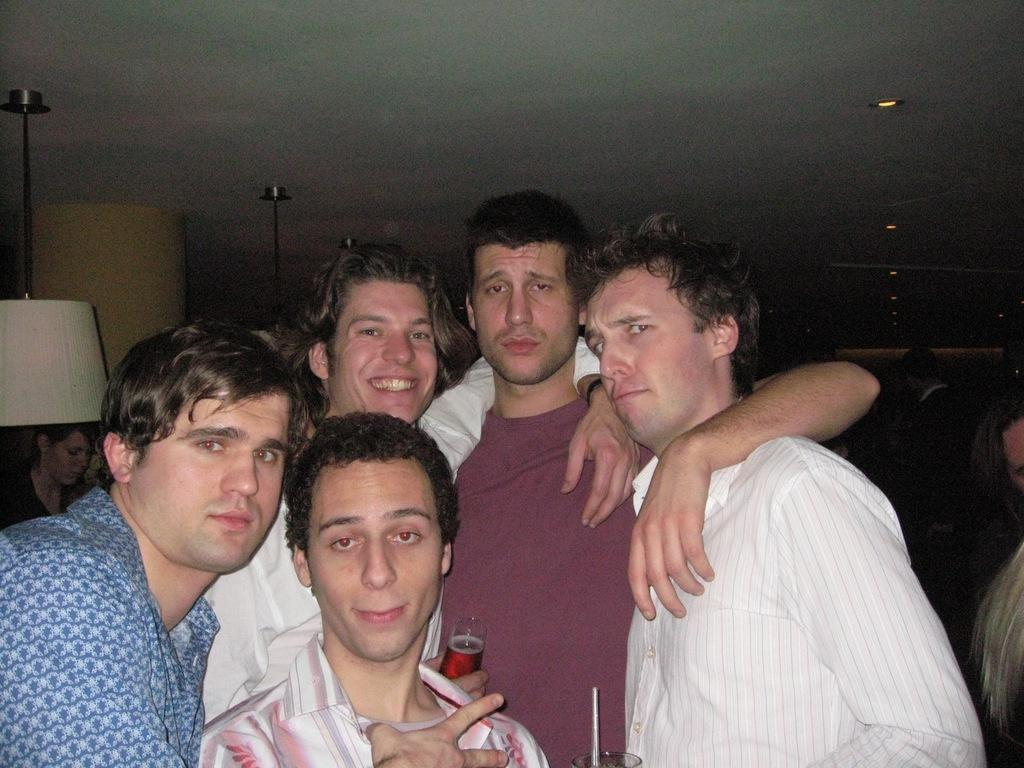Who or what can be seen in the image? There are people in the image. What is attached to the roof in the image? There are objects attached to the roof in the image. Can you describe any illumination in the image? There are lights visible in the image. What is the income of the person holding the pear in the image? There is no person holding a pear in the image, and therefore no income can be determined. 